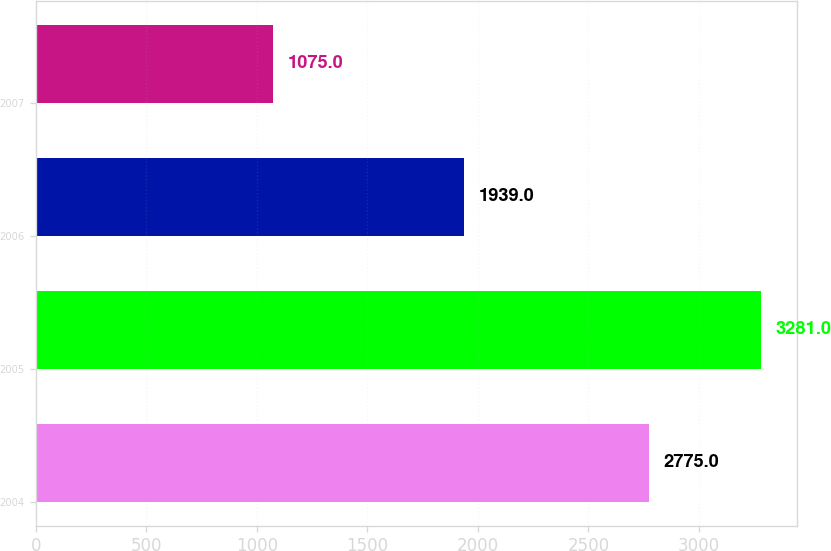Convert chart. <chart><loc_0><loc_0><loc_500><loc_500><bar_chart><fcel>2004<fcel>2005<fcel>2006<fcel>2007<nl><fcel>2775<fcel>3281<fcel>1939<fcel>1075<nl></chart> 